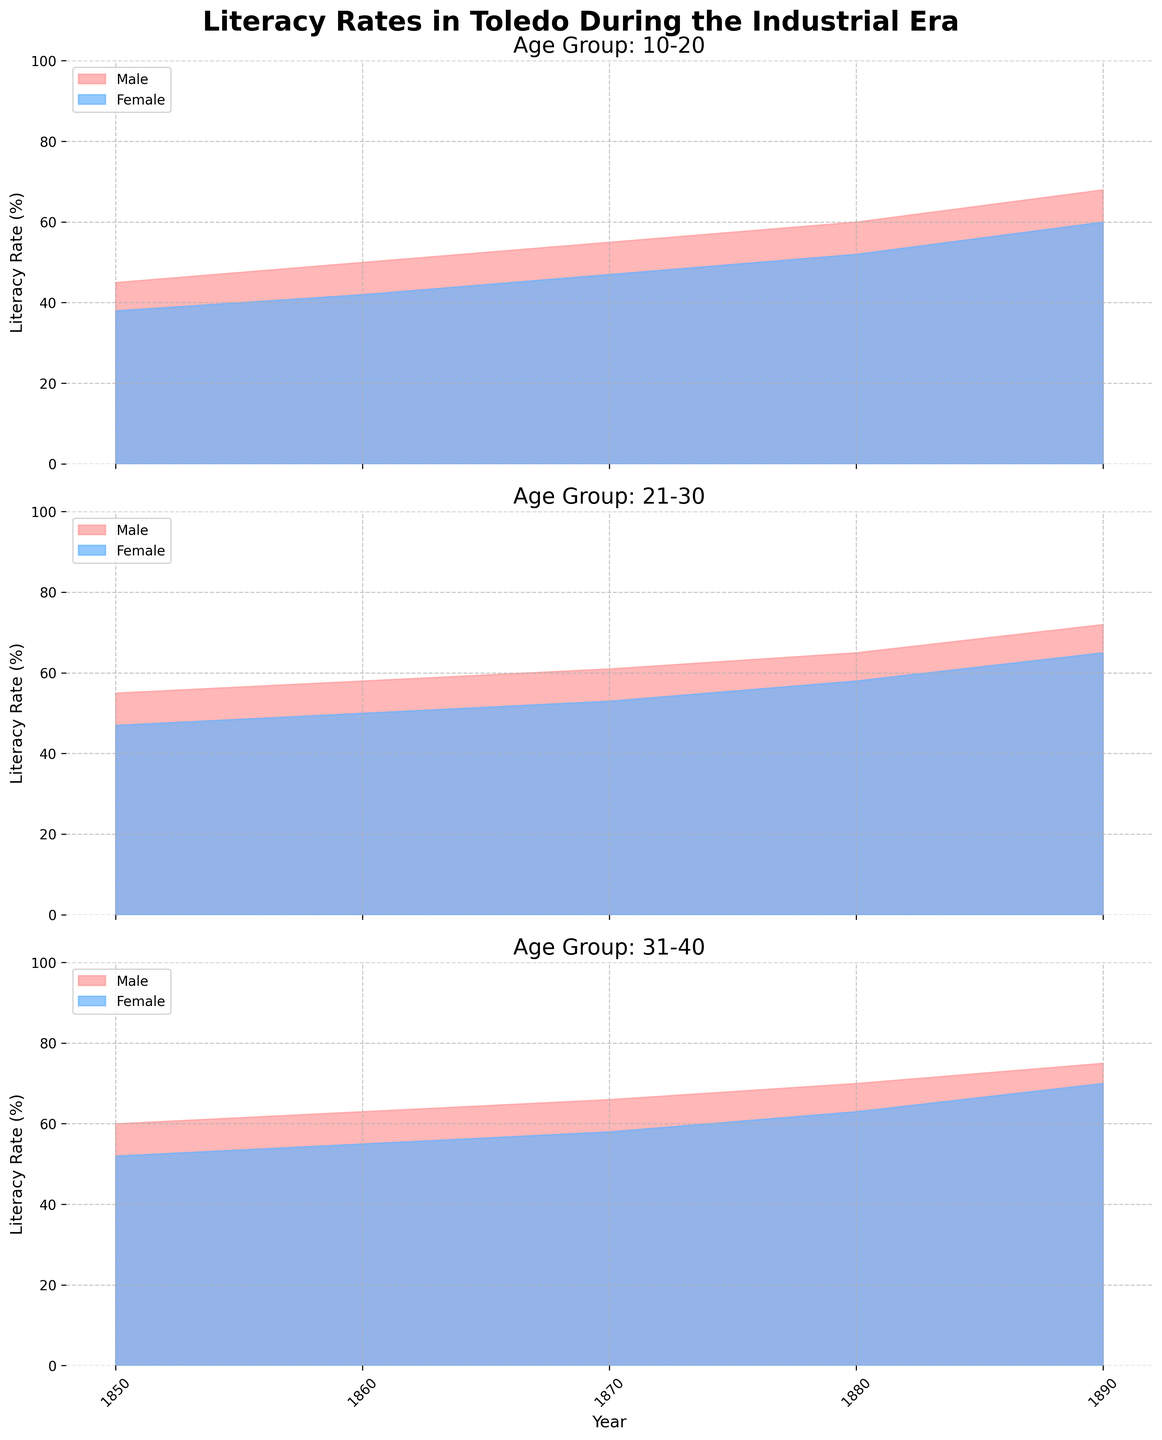What is the title of the figure? The title is located at the top of the figure and is usually the largest text. In this case, you can see it clearly as 'Literacy Rates in Toledo During the Industrial Era'.
Answer: 'Literacy Rates in Toledo During the Industrial Era' What are the labels on the y-axis? The y-axis appears on the left side of each subplot and is marked with "Literacy Rate (%)".
Answer: 'Literacy Rate (%)' Which age group had the highest male literacy rate in 1890? To find this, look at the 1890 data for each age group subplot ("10-20", "21-30", "31-40") where the blue shading represents males. The "31-40" age group shows the highest value, approaching 75%.
Answer: '31-40' How did the literacy rates change for females in the 21-30 age group from 1850 to 1890? Track the pink shading in the 21-30 age group subplot from 1850 to 1890. There is an increase from 47% in 1850 to 65% in 1890.
Answer: 'Increased from 47% to 65%' What is the average male literacy rate for the 10-20 age group across all years? Calculate the average by summing the literacy rates for the male 10-20 age group (45 in 1850, 50 in 1860, 55 in 1870, 60 in 1880, and 68 in 1890) and dividing by the number of data points. The sum is 278, and there are 5 years, so the average is 278/5 = 55.6%.
Answer: '55.6%' In which year did the 31-40 age group have the smallest gender gap in literacy rates? To find the smallest gender gap, examine the differences between male and female literacy rates in the 31-40 subplot across all years. In 1890, the gap is smallest at 5% (75% for males and 70% for females).
Answer: '1890' Which gender showed a higher increase in literacy rates for the 10-20 age group from 1850 to 1890? Compare the difference for males (68% in 1890 - 45% in 1850 = 23%) and females (60% in 1890 - 38% in 1850 = 22%). Males had a slightly higher increase by 1%.
Answer: 'Males' What trend is observed in the literacy rates of females in the 31-40 age group over the years? Look at the area shaded in pink in the 31-40 subplot for females and observe the upward trend from 52% in 1850 to 70% in 1890.
Answer: 'Upward trend' How does the literacy rate difference between males and females in the 21-30 age group in 1860 compare with that in 1880? Calculate the differences: In 1860, it's 58% - 50% = 8%, and in 1880, it's 65% - 58% = 7%. The gap slightly decreased by 1%.
Answer: 'Decreased by 1%' What can you say about the literacy rates of males in different age groups in 1860? Compare the literacy rates for males in different age group subplots for 1860. The rates increase with age: 50% in 10-20, 58% in 21-30, and 63% in 31-40.
Answer: 'Increase with age' 